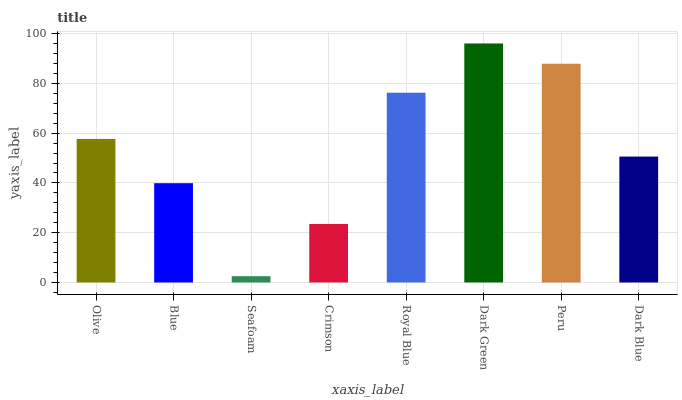Is Seafoam the minimum?
Answer yes or no. Yes. Is Dark Green the maximum?
Answer yes or no. Yes. Is Blue the minimum?
Answer yes or no. No. Is Blue the maximum?
Answer yes or no. No. Is Olive greater than Blue?
Answer yes or no. Yes. Is Blue less than Olive?
Answer yes or no. Yes. Is Blue greater than Olive?
Answer yes or no. No. Is Olive less than Blue?
Answer yes or no. No. Is Olive the high median?
Answer yes or no. Yes. Is Dark Blue the low median?
Answer yes or no. Yes. Is Crimson the high median?
Answer yes or no. No. Is Dark Green the low median?
Answer yes or no. No. 